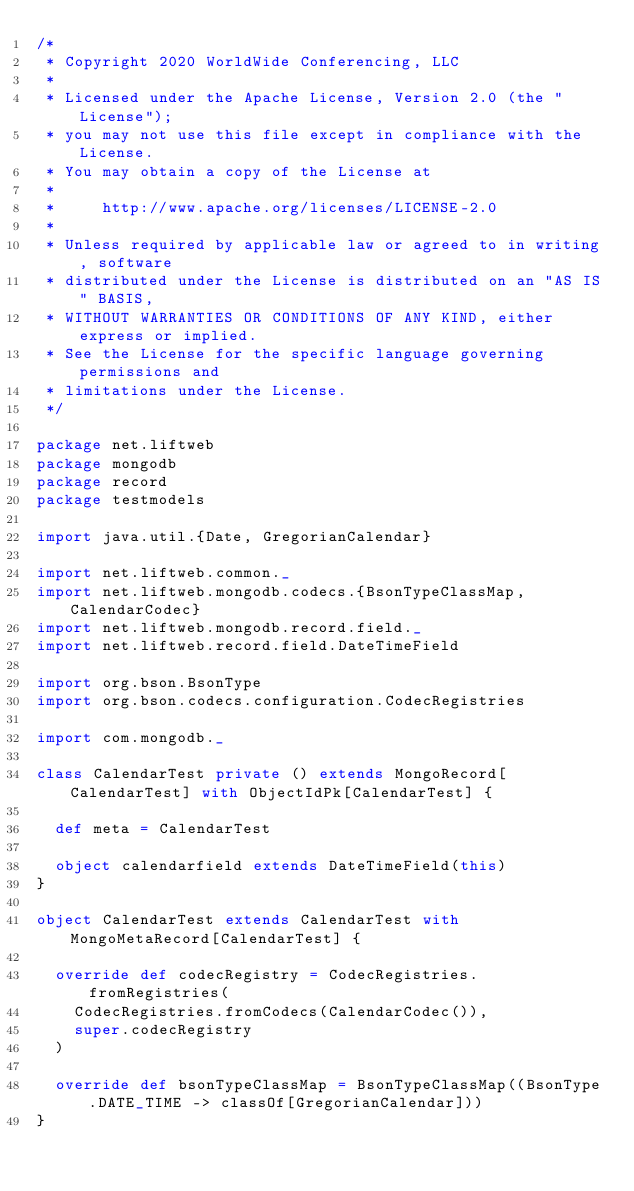Convert code to text. <code><loc_0><loc_0><loc_500><loc_500><_Scala_>/*
 * Copyright 2020 WorldWide Conferencing, LLC
 *
 * Licensed under the Apache License, Version 2.0 (the "License");
 * you may not use this file except in compliance with the License.
 * You may obtain a copy of the License at
 *
 *     http://www.apache.org/licenses/LICENSE-2.0
 *
 * Unless required by applicable law or agreed to in writing, software
 * distributed under the License is distributed on an "AS IS" BASIS,
 * WITHOUT WARRANTIES OR CONDITIONS OF ANY KIND, either express or implied.
 * See the License for the specific language governing permissions and
 * limitations under the License.
 */

package net.liftweb
package mongodb
package record
package testmodels

import java.util.{Date, GregorianCalendar}

import net.liftweb.common._
import net.liftweb.mongodb.codecs.{BsonTypeClassMap, CalendarCodec}
import net.liftweb.mongodb.record.field._
import net.liftweb.record.field.DateTimeField

import org.bson.BsonType
import org.bson.codecs.configuration.CodecRegistries

import com.mongodb._

class CalendarTest private () extends MongoRecord[CalendarTest] with ObjectIdPk[CalendarTest] {

  def meta = CalendarTest

  object calendarfield extends DateTimeField(this)
}

object CalendarTest extends CalendarTest with MongoMetaRecord[CalendarTest] {

  override def codecRegistry = CodecRegistries.fromRegistries(
    CodecRegistries.fromCodecs(CalendarCodec()),
    super.codecRegistry
  )

  override def bsonTypeClassMap = BsonTypeClassMap((BsonType.DATE_TIME -> classOf[GregorianCalendar]))
}
</code> 